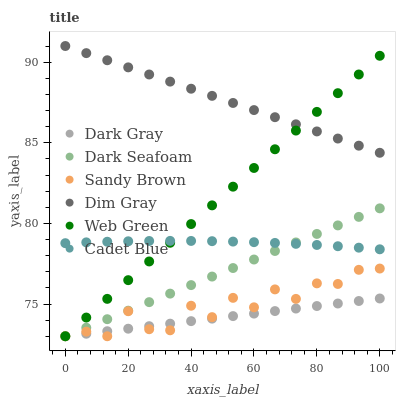Does Dark Gray have the minimum area under the curve?
Answer yes or no. Yes. Does Dim Gray have the maximum area under the curve?
Answer yes or no. Yes. Does Web Green have the minimum area under the curve?
Answer yes or no. No. Does Web Green have the maximum area under the curve?
Answer yes or no. No. Is Dark Gray the smoothest?
Answer yes or no. Yes. Is Sandy Brown the roughest?
Answer yes or no. Yes. Is Web Green the smoothest?
Answer yes or no. No. Is Web Green the roughest?
Answer yes or no. No. Does Web Green have the lowest value?
Answer yes or no. Yes. Does Dim Gray have the lowest value?
Answer yes or no. No. Does Dim Gray have the highest value?
Answer yes or no. Yes. Does Web Green have the highest value?
Answer yes or no. No. Is Sandy Brown less than Dim Gray?
Answer yes or no. Yes. Is Dim Gray greater than Cadet Blue?
Answer yes or no. Yes. Does Dark Seafoam intersect Dark Gray?
Answer yes or no. Yes. Is Dark Seafoam less than Dark Gray?
Answer yes or no. No. Is Dark Seafoam greater than Dark Gray?
Answer yes or no. No. Does Sandy Brown intersect Dim Gray?
Answer yes or no. No. 